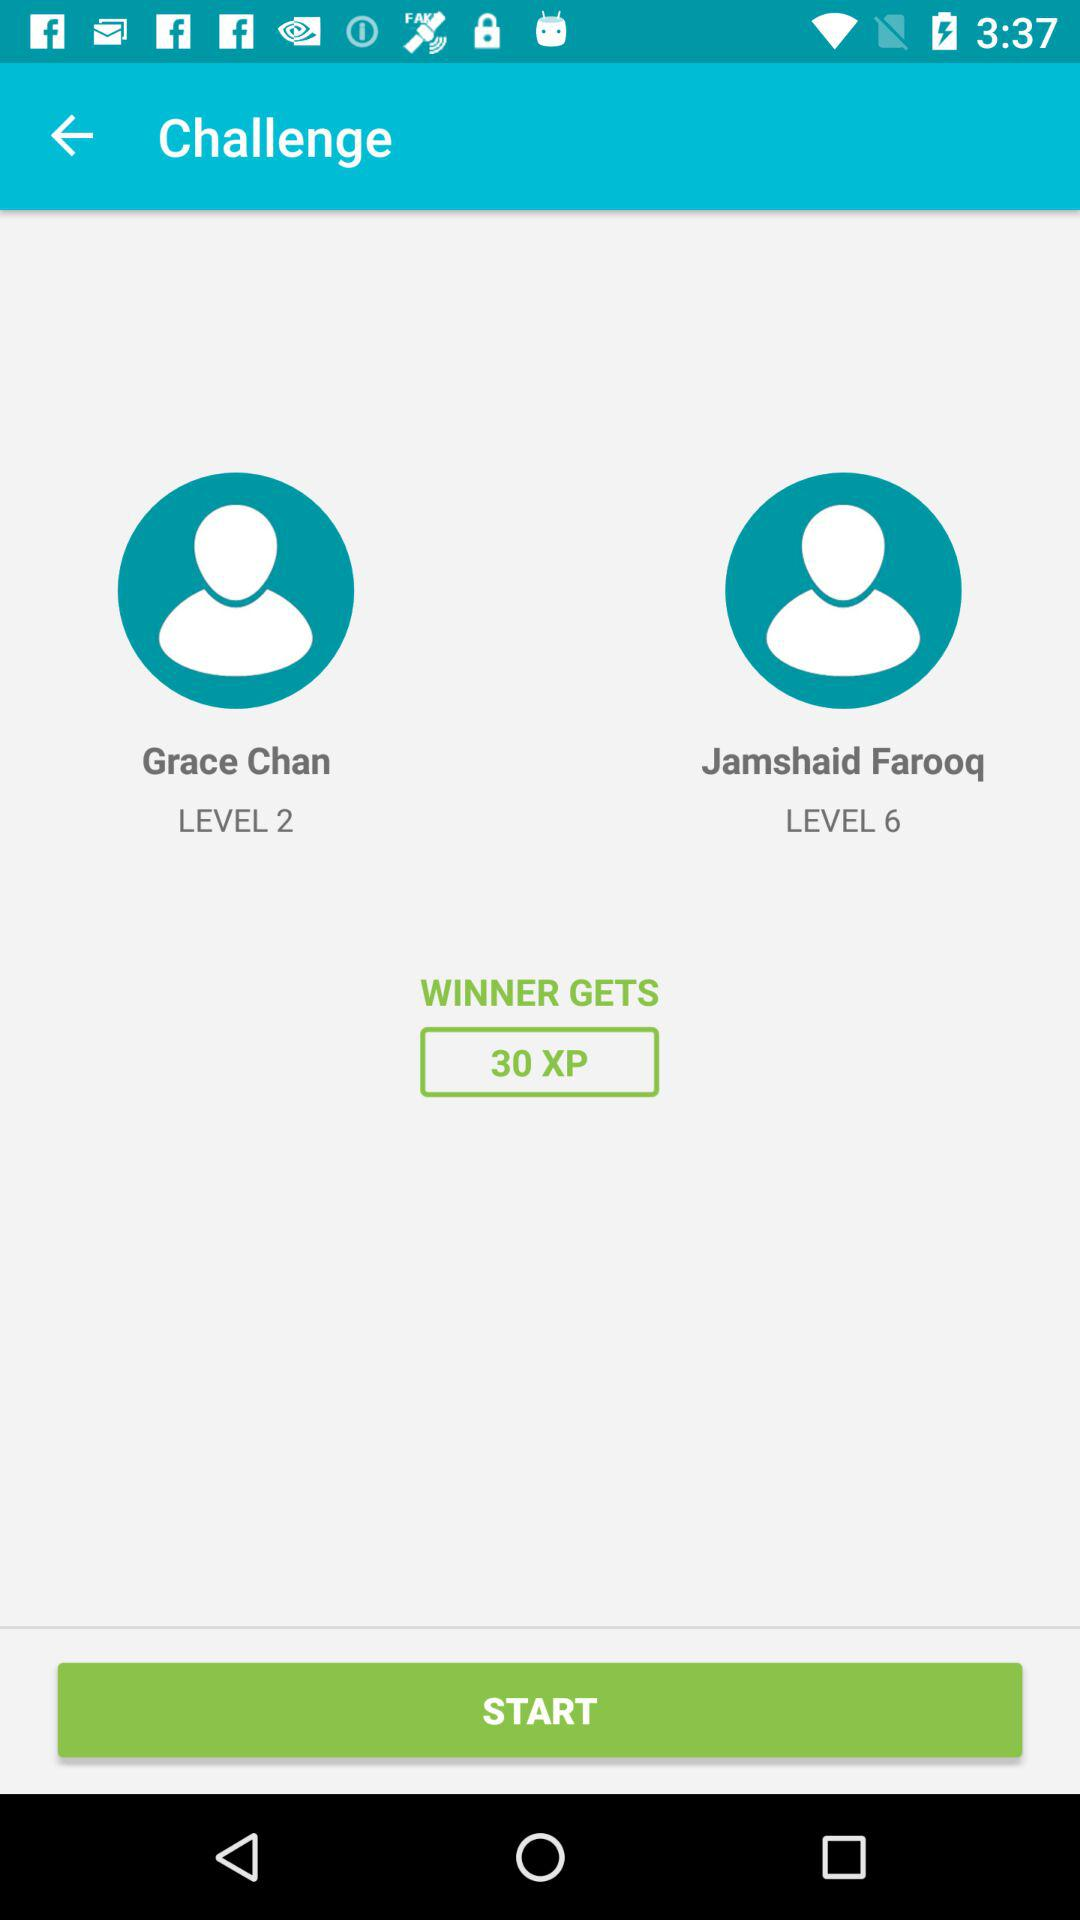Which user is on level six? The user is Jamshaid Farooq. 